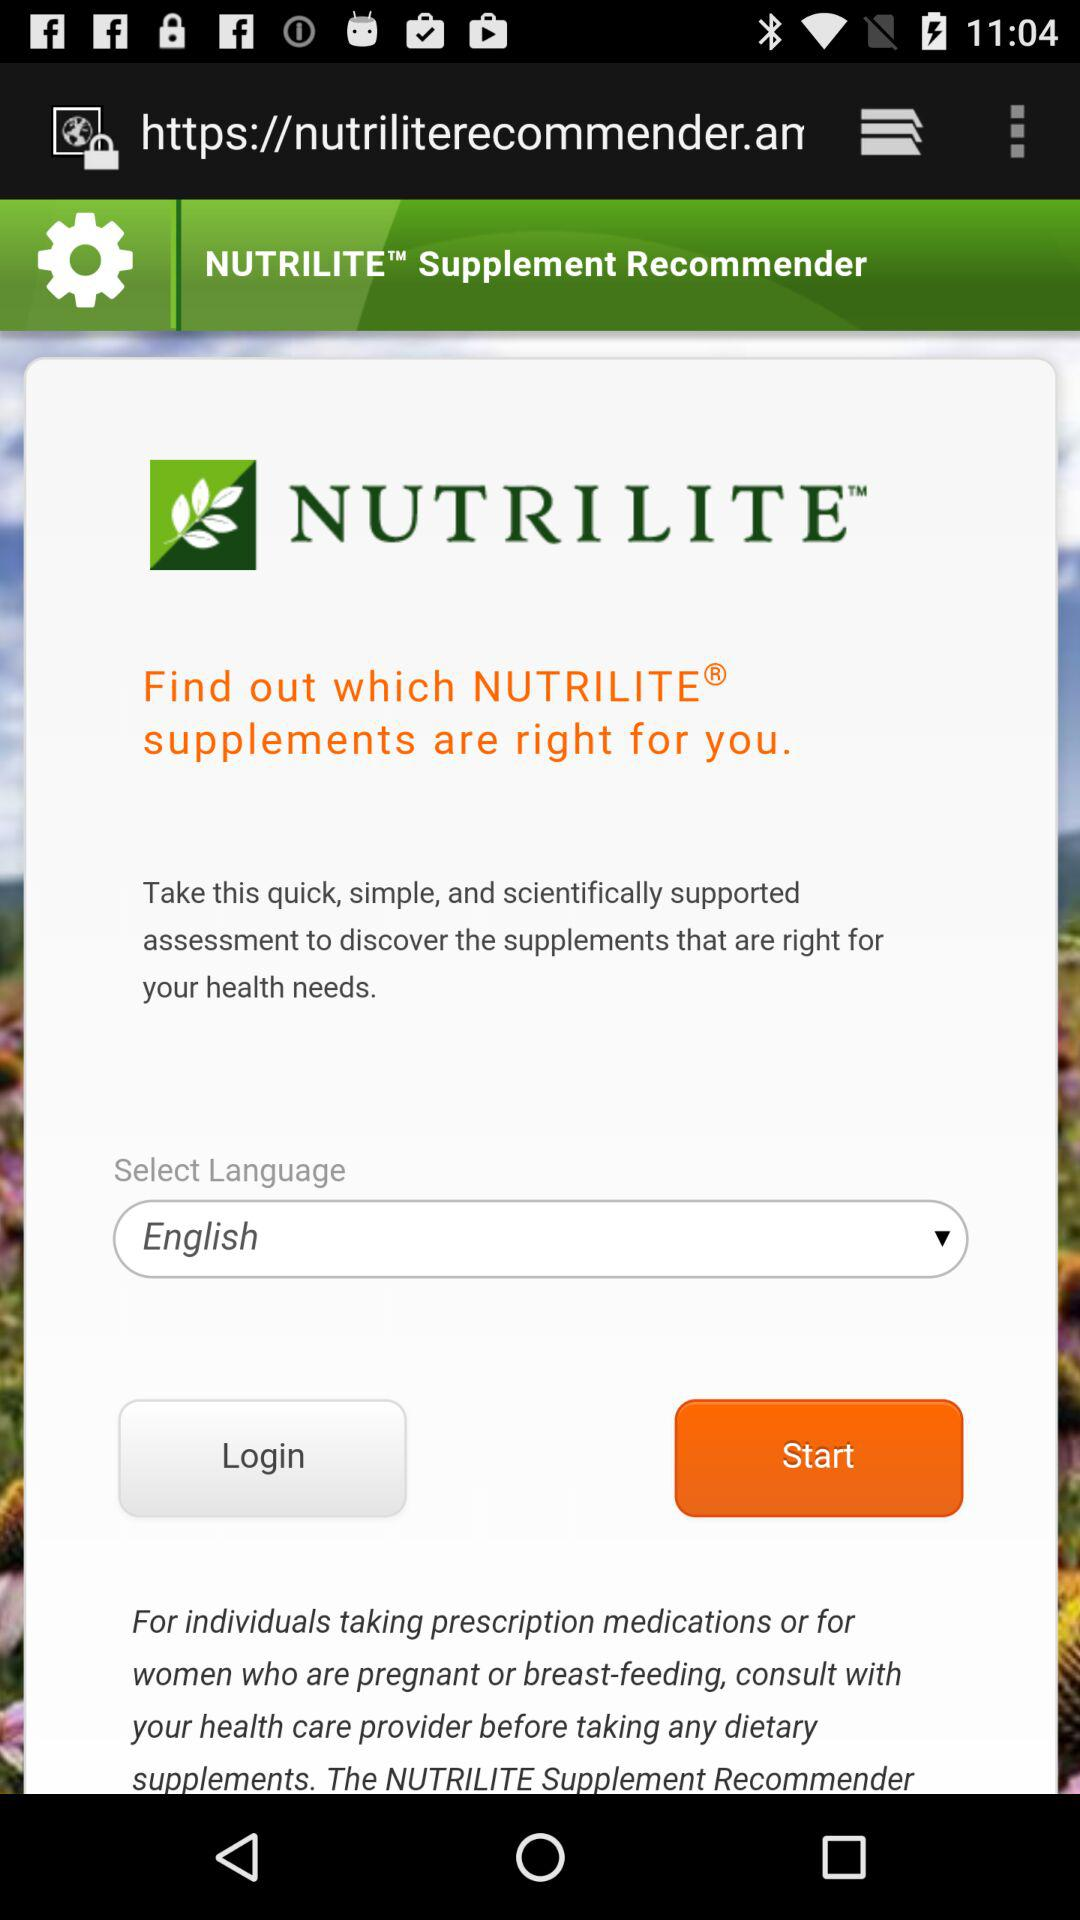What is the selected language? The selected language is English. 